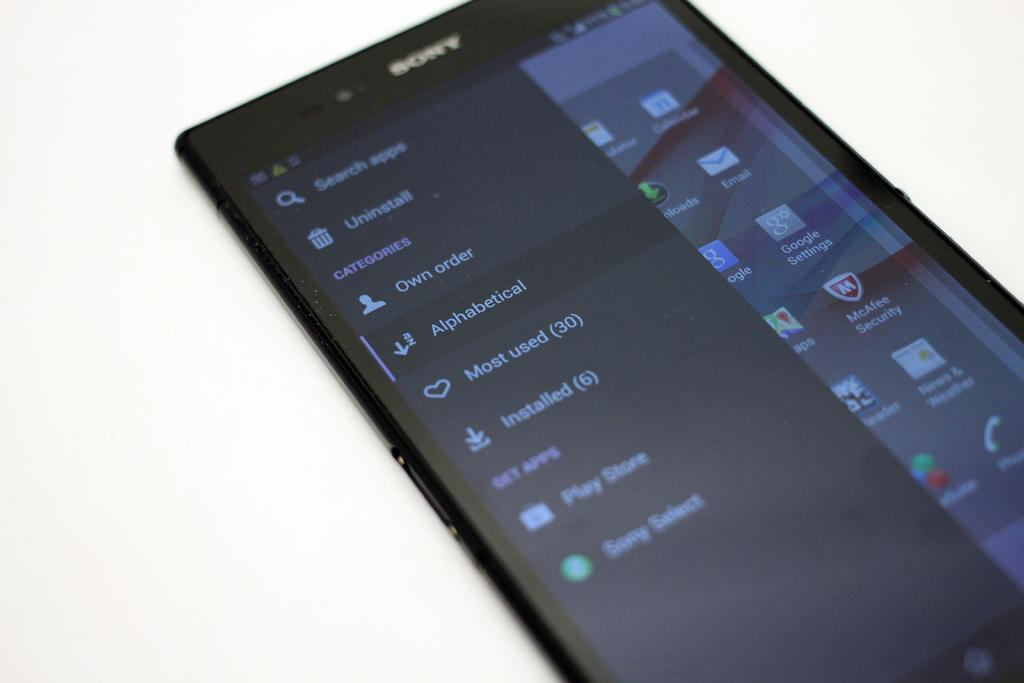Provide a one-sentence caption for the provided image. A Sony phone screen has an uninstall icon near the top. 